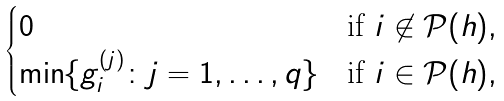<formula> <loc_0><loc_0><loc_500><loc_500>\begin{cases} 0 & \text {if } i \not \in \mathcal { P } ( h ) , \\ \min \{ g ^ { ( j ) } _ { i } \colon j = 1 , \dots , q \} & \text {if } i \in \mathcal { P } ( h ) , \end{cases}</formula> 